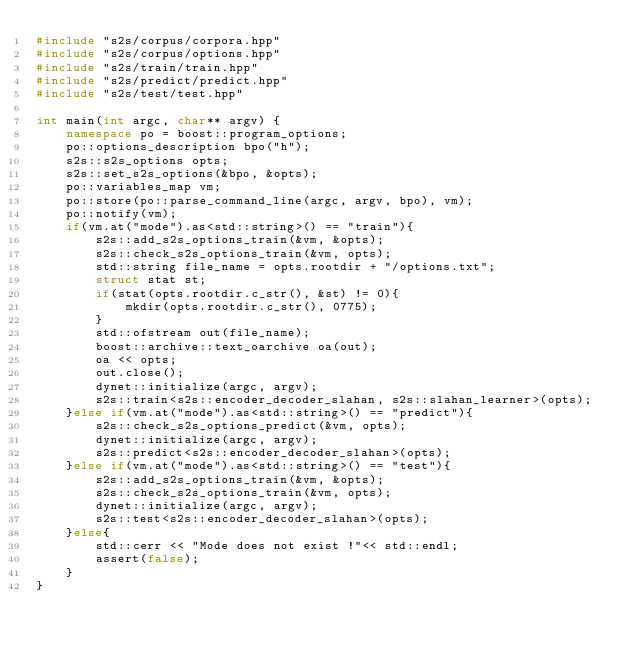<code> <loc_0><loc_0><loc_500><loc_500><_C++_>#include "s2s/corpus/corpora.hpp"
#include "s2s/corpus/options.hpp"
#include "s2s/train/train.hpp"
#include "s2s/predict/predict.hpp"
#include "s2s/test/test.hpp"

int main(int argc, char** argv) {
    namespace po = boost::program_options;
    po::options_description bpo("h");
    s2s::s2s_options opts;
    s2s::set_s2s_options(&bpo, &opts);
    po::variables_map vm;
    po::store(po::parse_command_line(argc, argv, bpo), vm);
    po::notify(vm);
    if(vm.at("mode").as<std::string>() == "train"){
        s2s::add_s2s_options_train(&vm, &opts);
        s2s::check_s2s_options_train(&vm, opts);
        std::string file_name = opts.rootdir + "/options.txt";
        struct stat st;
        if(stat(opts.rootdir.c_str(), &st) != 0){
            mkdir(opts.rootdir.c_str(), 0775);
        }
        std::ofstream out(file_name);
        boost::archive::text_oarchive oa(out);
        oa << opts;
        out.close();
        dynet::initialize(argc, argv);
        s2s::train<s2s::encoder_decoder_slahan, s2s::slahan_learner>(opts);
    }else if(vm.at("mode").as<std::string>() == "predict"){
        s2s::check_s2s_options_predict(&vm, opts);
        dynet::initialize(argc, argv);
        s2s::predict<s2s::encoder_decoder_slahan>(opts);
    }else if(vm.at("mode").as<std::string>() == "test"){
        s2s::add_s2s_options_train(&vm, &opts);
        s2s::check_s2s_options_train(&vm, opts);
        dynet::initialize(argc, argv);
        s2s::test<s2s::encoder_decoder_slahan>(opts);
    }else{
        std::cerr << "Mode does not exist !"<< std::endl;
        assert(false);
    }
}
</code> 